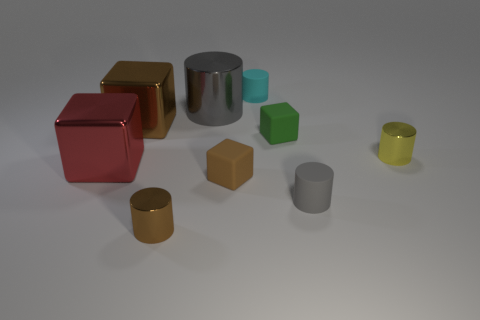Subtract all yellow cylinders. How many cylinders are left? 4 Subtract all cyan rubber cylinders. How many cylinders are left? 4 Subtract all red cylinders. Subtract all gray balls. How many cylinders are left? 5 Add 1 purple metallic blocks. How many objects exist? 10 Subtract all cylinders. How many objects are left? 4 Subtract 0 cyan spheres. How many objects are left? 9 Subtract all small green blocks. Subtract all metallic things. How many objects are left? 3 Add 9 small green objects. How many small green objects are left? 10 Add 8 small green rubber things. How many small green rubber things exist? 9 